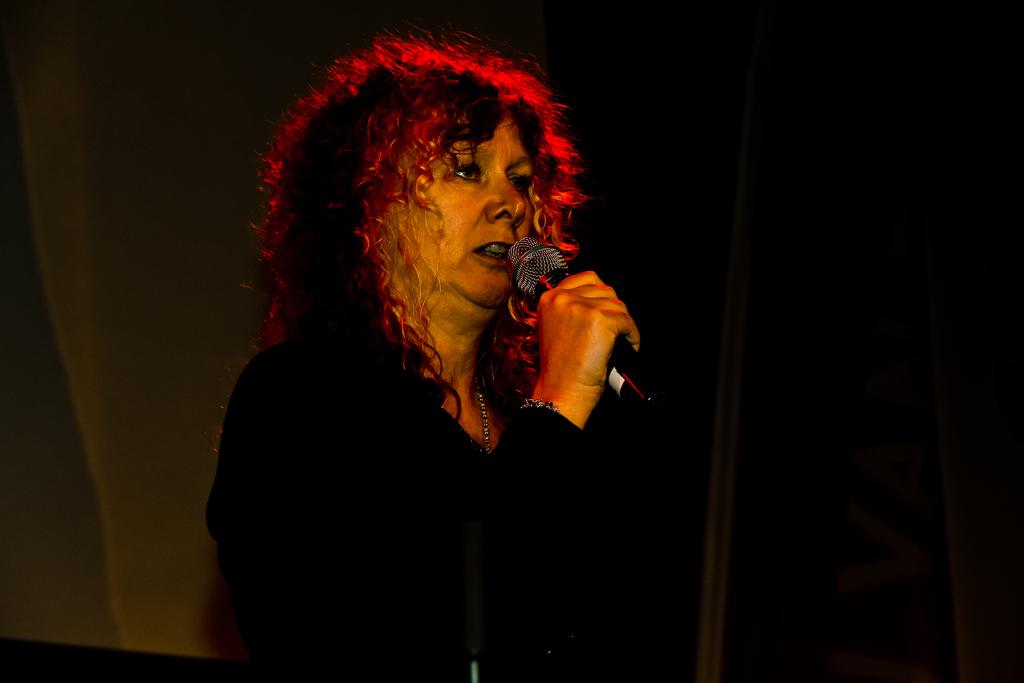Who is the main subject in the image? There is a woman in the image. What is the woman holding in the image? The woman is holding a mic. Can you describe the background of the image? The background of the image is not clear. Is there a boat visible in the image? No, there is no boat present in the image. What type of zinc is being used in the image? There is no zinc present in the image. 